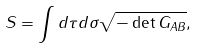<formula> <loc_0><loc_0><loc_500><loc_500>S = \int d \tau d \sigma \sqrt { - \det G _ { A B } } ,</formula> 